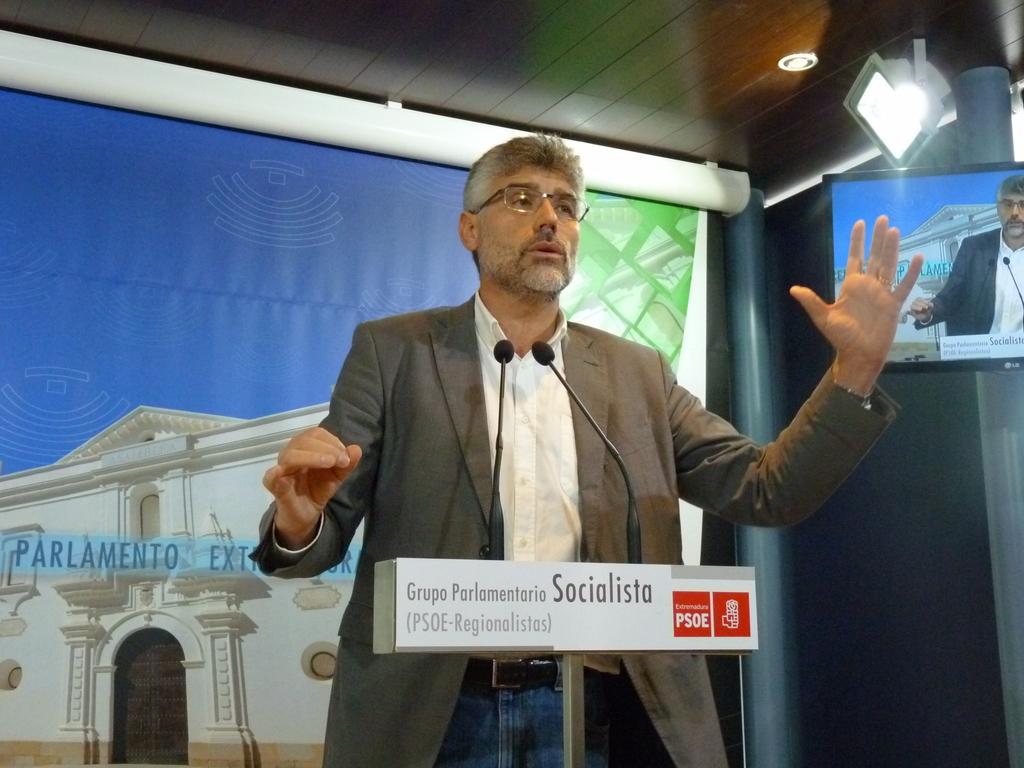How would you summarize this image in a sentence or two? In this image there is men standing in front of a podium, on that podium there are mice and there is some text written, in the background there is poster on that poster there is building and there is some text, on the right side there is a monitor, at top there is ceiling and lights. 